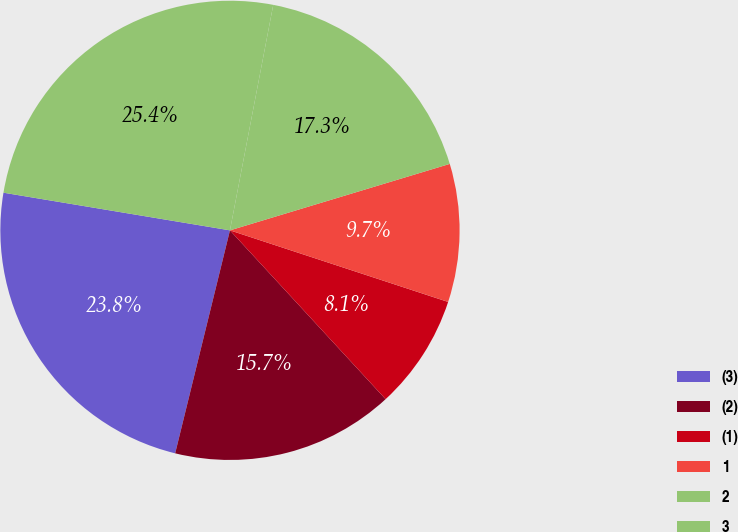Convert chart to OTSL. <chart><loc_0><loc_0><loc_500><loc_500><pie_chart><fcel>(3)<fcel>(2)<fcel>(1)<fcel>1<fcel>2<fcel>3<nl><fcel>23.79%<fcel>15.69%<fcel>8.1%<fcel>9.72%<fcel>17.31%<fcel>25.4%<nl></chart> 